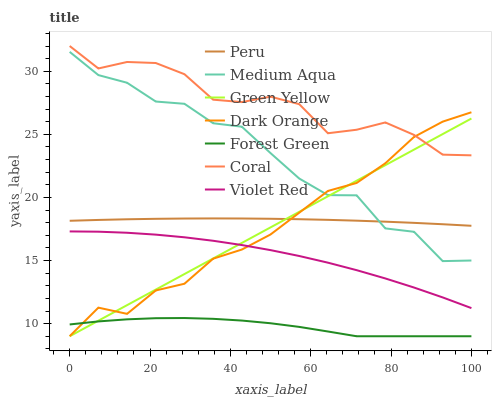Does Violet Red have the minimum area under the curve?
Answer yes or no. No. Does Violet Red have the maximum area under the curve?
Answer yes or no. No. Is Violet Red the smoothest?
Answer yes or no. No. Is Violet Red the roughest?
Answer yes or no. No. Does Violet Red have the lowest value?
Answer yes or no. No. Does Violet Red have the highest value?
Answer yes or no. No. Is Forest Green less than Coral?
Answer yes or no. Yes. Is Medium Aqua greater than Forest Green?
Answer yes or no. Yes. Does Forest Green intersect Coral?
Answer yes or no. No. 